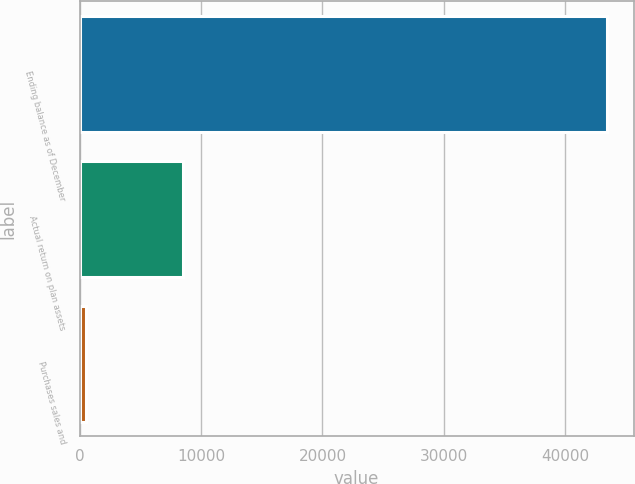<chart> <loc_0><loc_0><loc_500><loc_500><bar_chart><fcel>Ending balance as of December<fcel>Actual return on plan assets<fcel>Purchases sales and<nl><fcel>43458.4<fcel>8525<fcel>528<nl></chart> 